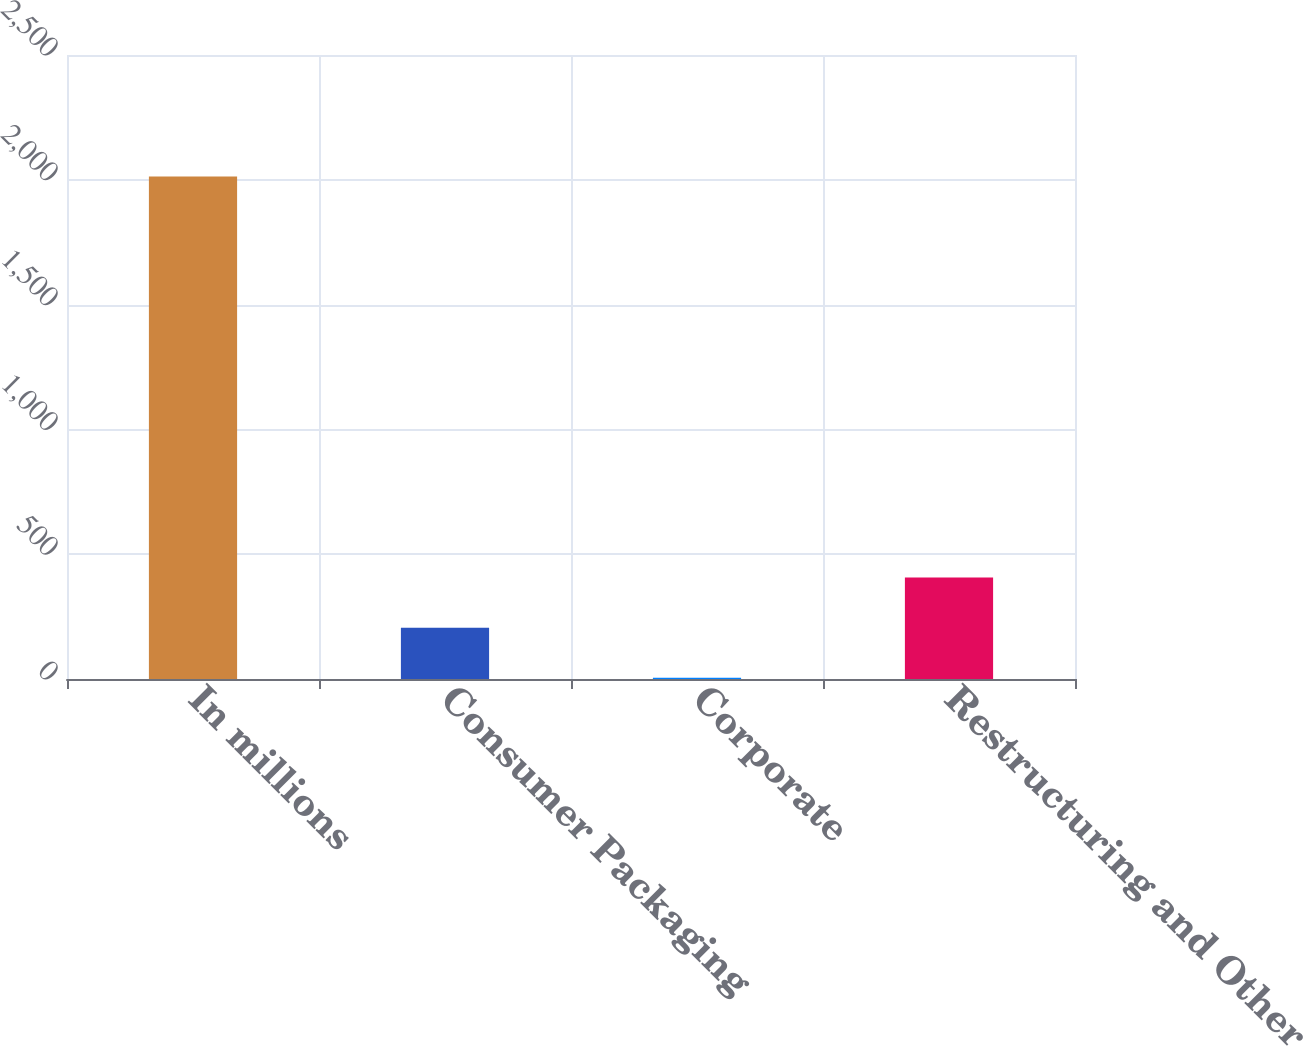<chart> <loc_0><loc_0><loc_500><loc_500><bar_chart><fcel>In millions<fcel>Consumer Packaging<fcel>Corporate<fcel>Restructuring and Other<nl><fcel>2013<fcel>205.8<fcel>5<fcel>406.6<nl></chart> 